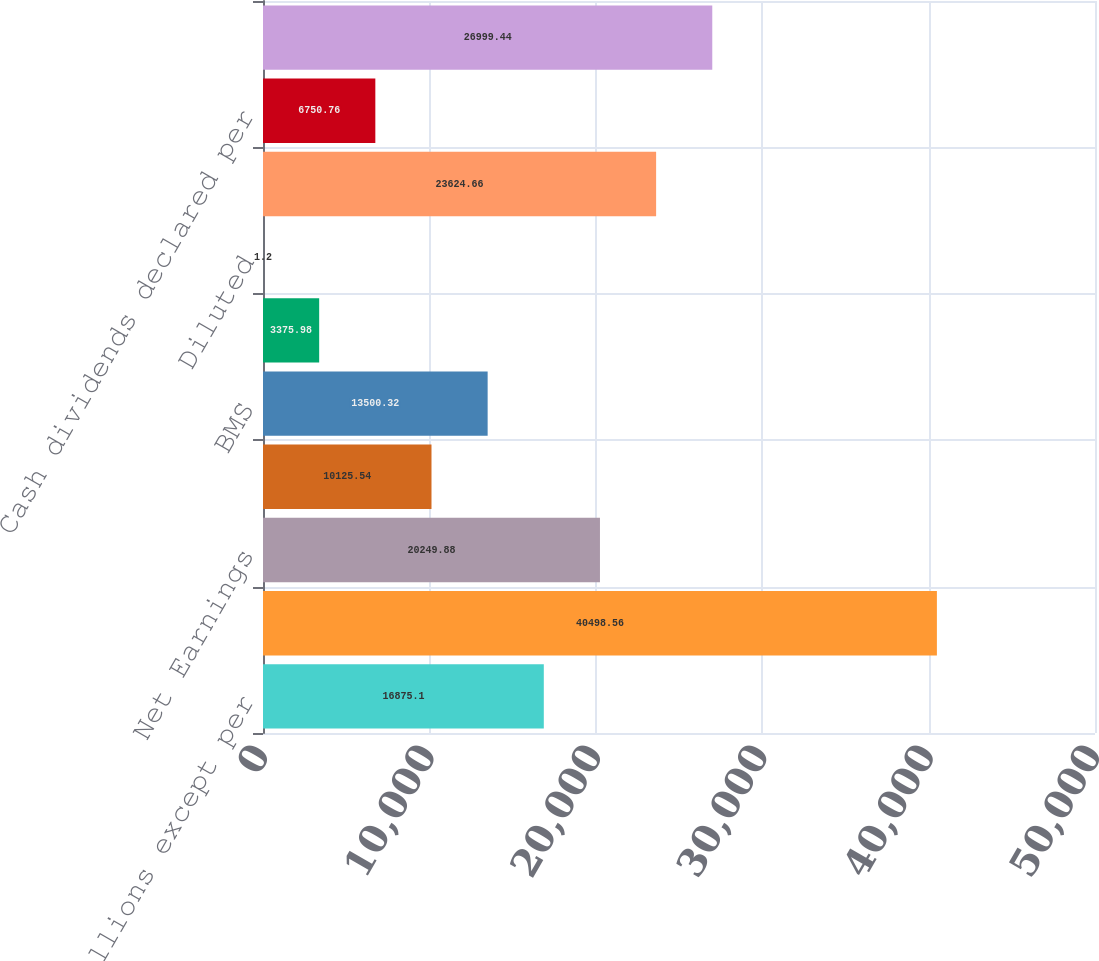Convert chart. <chart><loc_0><loc_0><loc_500><loc_500><bar_chart><fcel>Amounts in Millions except per<fcel>Total Revenues<fcel>Net Earnings<fcel>Noncontrolling Interest<fcel>BMS<fcel>Basic<fcel>Diluted<fcel>Cash dividends paid on BMS<fcel>Cash dividends declared per<fcel>Cash and cash equivalents<nl><fcel>16875.1<fcel>40498.6<fcel>20249.9<fcel>10125.5<fcel>13500.3<fcel>3375.98<fcel>1.2<fcel>23624.7<fcel>6750.76<fcel>26999.4<nl></chart> 